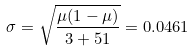<formula> <loc_0><loc_0><loc_500><loc_500>\sigma = \sqrt { \frac { \mu ( 1 - \mu ) } { 3 + 5 1 } } = 0 . 0 4 6 1</formula> 